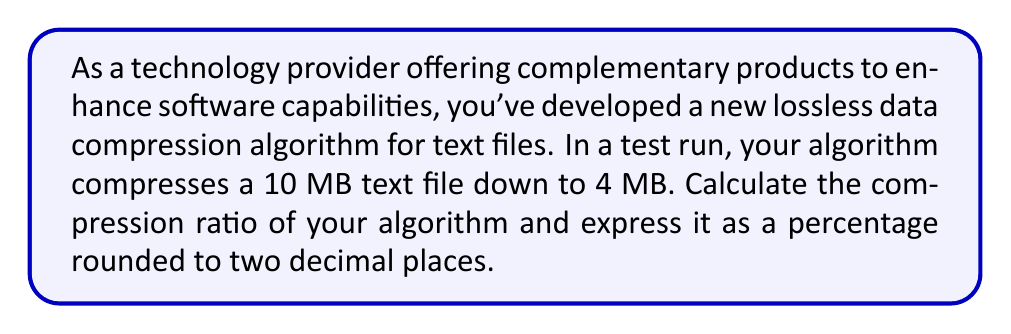Teach me how to tackle this problem. To solve this problem, we need to understand the concept of compression ratio and how to calculate it.

1. Compression Ratio Definition:
   The compression ratio is defined as the ratio of the uncompressed size to the compressed size.

   $$ \text{Compression Ratio} = \frac{\text{Uncompressed Size}}{\text{Compressed Size}} $$

2. Given Information:
   - Uncompressed size: 10 MB
   - Compressed size: 4 MB

3. Calculate the Compression Ratio:
   $$ \text{Compression Ratio} = \frac{10 \text{ MB}}{4 \text{ MB}} = 2.5 $$

4. Convert to Percentage:
   To express the compression ratio as a percentage, we subtract 1 from the ratio and multiply by 100:

   $$ \text{Compression Percentage} = (\text{Compression Ratio} - 1) \times 100\% $$
   $$ = (2.5 - 1) \times 100\% = 1.5 \times 100\% = 150\% $$

5. Round to Two Decimal Places:
   The result is already expressed to two decimal places, so no further rounding is necessary.

This compression percentage indicates that the original file size has been reduced by 150% of its compressed size, or in other words, the algorithm has achieved a 60% reduction in file size.
Answer: 150.00% 